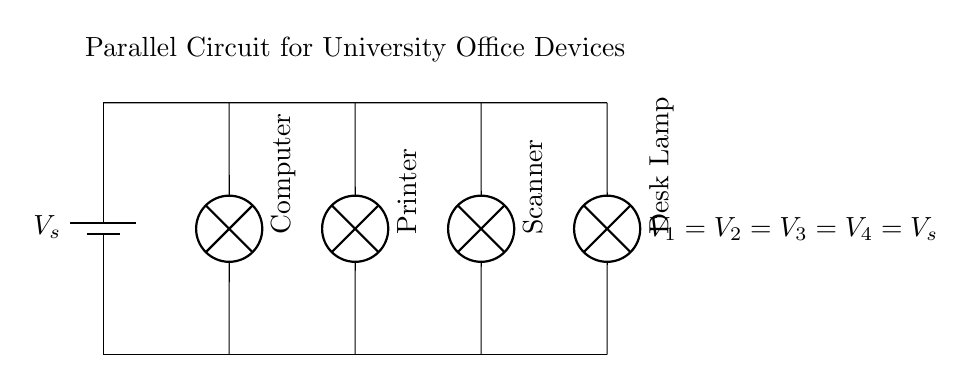What type of circuit is represented? The circuit is a parallel circuit, which can be identified by the branches connecting multiple devices directly to the power source, allowing each to operate independently.
Answer: Parallel How many devices are connected in the circuit? There are four devices connected in the circuit, which can be counted by observing the distinct branches leading to each device from the power source.
Answer: Four What is the voltage across the printer? The voltage across the printer is the same as the power source voltage, as all devices in a parallel circuit share this voltage.
Answer: Vs What does each device represent? Each device in the circuit represents a specific electronic item - a computer, printer, scanner, and desk lamp, respectively, as labeled in the diagram.
Answer: Computer, printer, scanner, desk lamp If one device fails, what happens to the others? If one device fails in a parallel circuit, the others continue to operate normally, as the failure does not interrupt the power supply to the other branches.
Answer: They continue to operate What type of connection is used for the devices? The devices are connected via branches, which is a hallmark of parallel circuits where all components have their own distinct paths to the power source.
Answer: Branches 